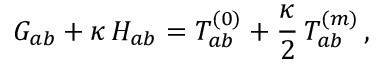<formula> <loc_0><loc_0><loc_500><loc_500>G _ { a b } + \kappa \, H _ { a b } = T _ { a b } ^ { ( 0 ) } + \frac { \kappa } { 2 } \, T _ { a b } ^ { ( m ) } \, ,</formula> 